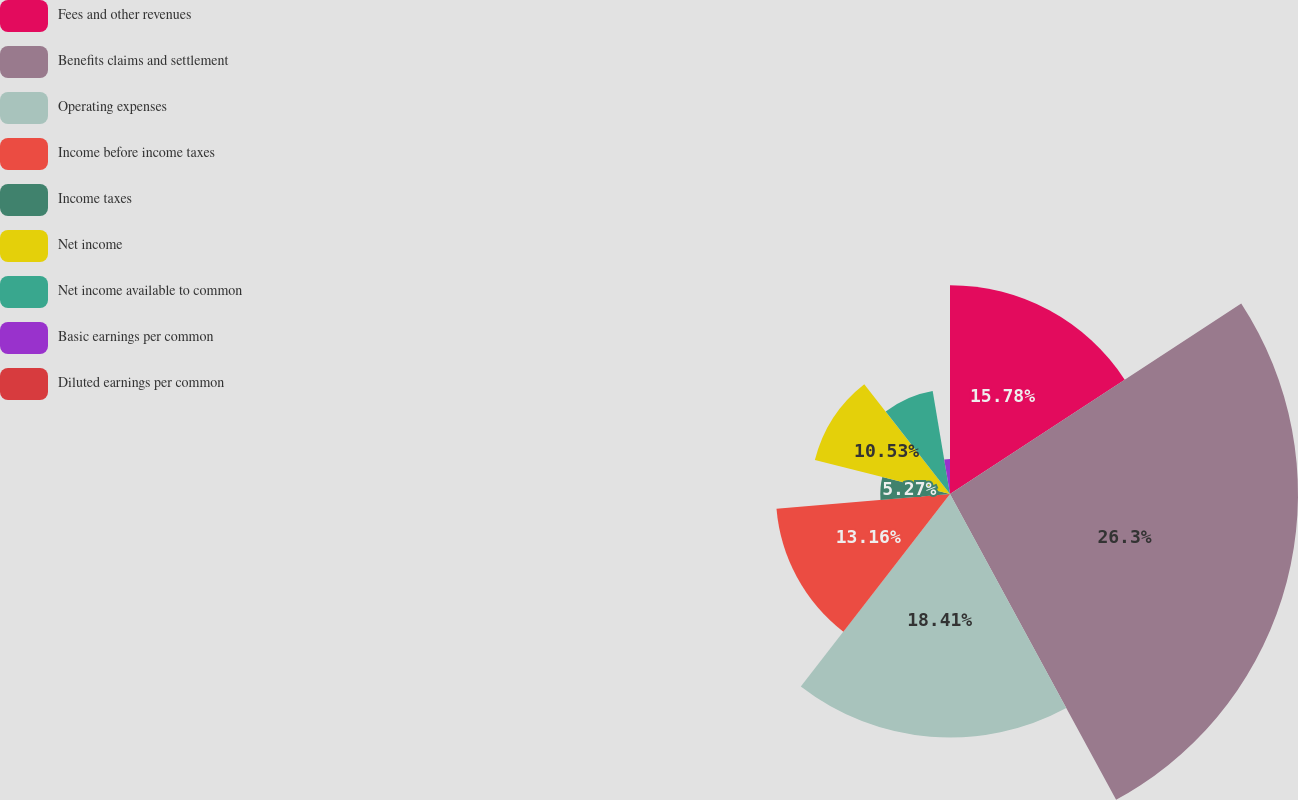Convert chart to OTSL. <chart><loc_0><loc_0><loc_500><loc_500><pie_chart><fcel>Fees and other revenues<fcel>Benefits claims and settlement<fcel>Operating expenses<fcel>Income before income taxes<fcel>Income taxes<fcel>Net income<fcel>Net income available to common<fcel>Basic earnings per common<fcel>Diluted earnings per common<nl><fcel>15.78%<fcel>26.3%<fcel>18.41%<fcel>13.16%<fcel>5.27%<fcel>10.53%<fcel>7.9%<fcel>2.64%<fcel>0.01%<nl></chart> 